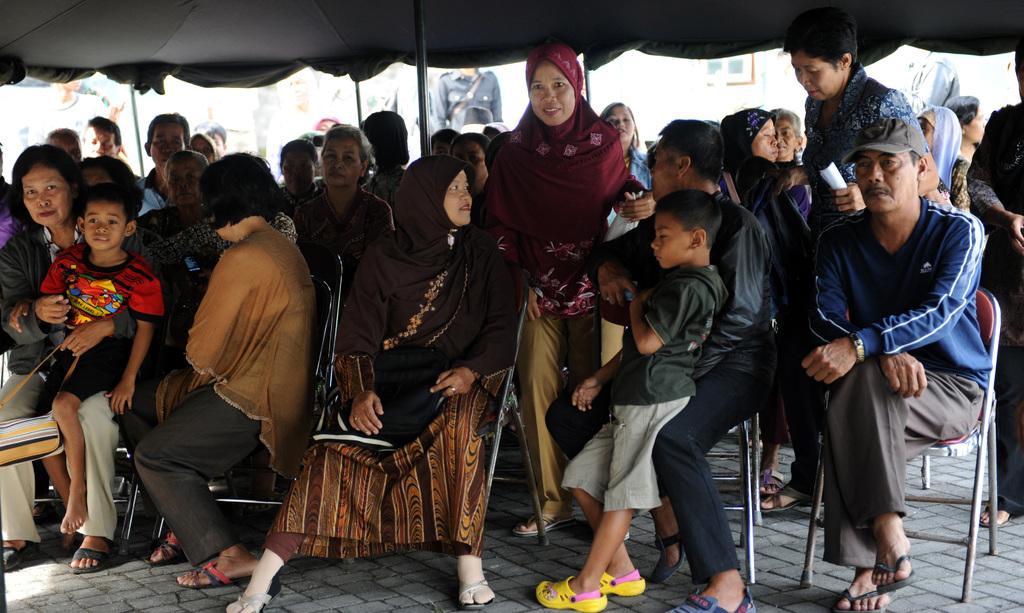How would you summarize this image in a sentence or two? This picture seems to be clicked under the tent. In the foreground we can see the group of people sitting on the chairs and we can see the two people holding some objects and seems to be walking on the pavement. In the background we can see the metal rods, group of people seems to be standing on the ground and we can see many other objects. 